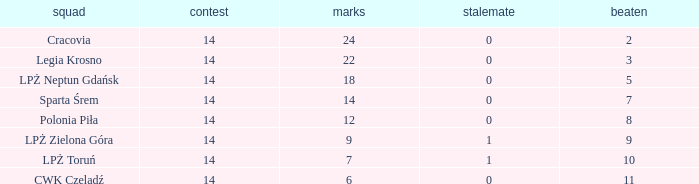What is the sum for the match with a draw less than 0? None. 